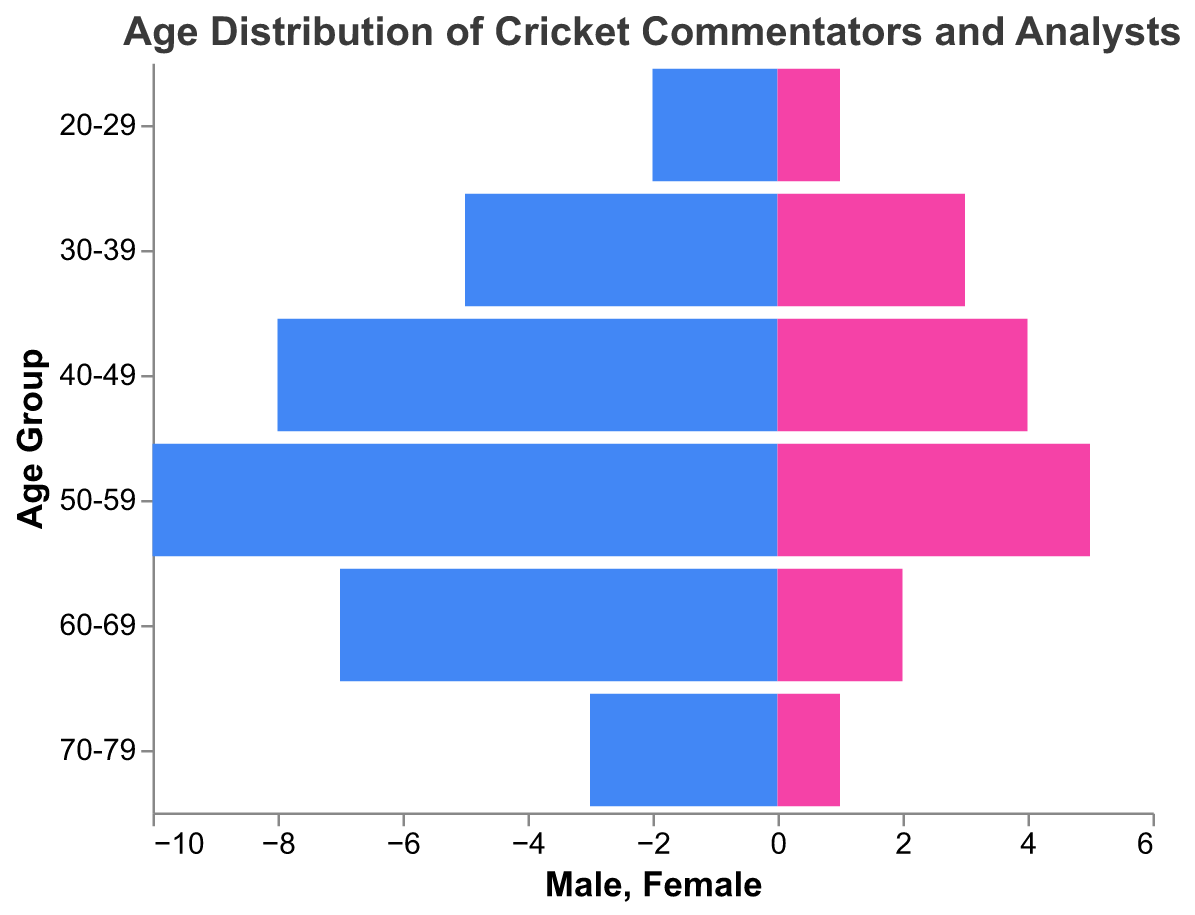How many age groups are shown in the figure? The figure shows the total number of age groups on the y-axis. Counting the distinct age group labels from "20-29" to "70-79" gives us 6 age groups.
Answer: 6 What is the age group with the highest number of male commentators and analysts? By comparing the lengths of the blue bars (representing males) for each age group, the age group "50-59" has the highest count with a value of 10.
Answer: 50-59 How many more male commentators and analysts are there in the "50-59" age group compared to the "60-69" age group? Subtract the number of male commentators and analysts in the "60-69" group (7) from those in the "50-59" group (10). The difference is 10 - 7 = 3.
Answer: 3 What is the total number of female commentators and analysts in the 30-39 and 40-49 age groups combined? Add the number of female commentators and analysts in both age groups: 3 (30-39) + 4 (40-49) = 7.
Answer: 7 Which gender has a higher count in the "20-29" age group, and by how much? Compare the number of male commentators and analysts (2) with females (1) in the "20-29" age group. Males are higher by a difference of 2 - 1 = 1.
Answer: Male, 1 What is the sum of male and female commentators and analysts in the "70-79" age group? Add the number of male and female commentators and analysts in the "70-79" age group: 3 (male) + 1 (female) = 4.
Answer: 4 Which age group has the most balanced numbers between male and female commentators and analysts? For each age group, calculate the absolute difference between the number of male and female commentators and analysts: 
- 20-29: abs(2-1) = 1
- 30-39: abs(5-3) = 2
- 40-49: abs(8-4) = 4
- 50-59: abs(10-5) = 5
- 60-69: abs(7-2) = 5
- 70-79: abs(3-1) = 2
The age group 20-29 has the smallest difference of 1, making it the most balanced.
Answer: 20-29 In which age group is there the largest numerical gap between the number of male and female commentators and analysts? Calculate the differences between male and female commentators and analysts for each age group:
- 20-29: abs(2-1) = 1
- 30-39: abs(5-3) = 2
- 40-49: abs(8-4) = 4
- 50-59: abs(10-5) = 5
- 60-69: abs(7-2) = 5
- 70-79: abs(3-1) = 2
The age group 50-59 and 60-69 both have the largest gap with a difference of 5.
Answer: 50-59 and 60-69 What's the average number of female commentators and analysts across all age groups? Sum the number of female commentators and analysts from each age group (1 + 3 + 4 + 5 + 2 + 1 = 16) and divide by the number of age groups (6) to find the average: 16 / 6 ≈ 2.67.
Answer: 2.67 